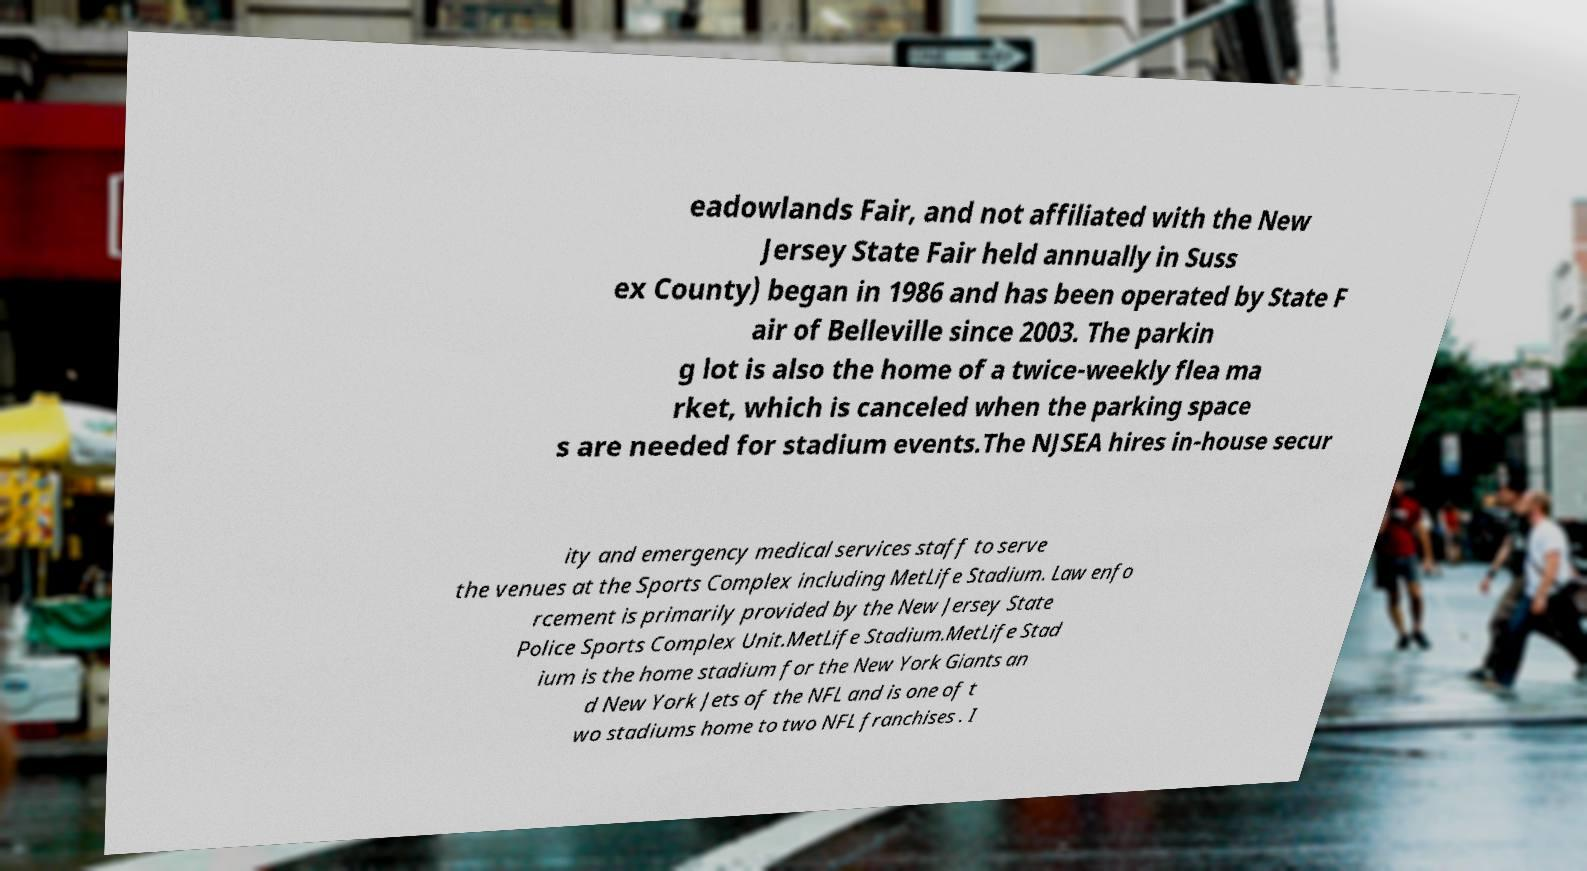For documentation purposes, I need the text within this image transcribed. Could you provide that? eadowlands Fair, and not affiliated with the New Jersey State Fair held annually in Suss ex County) began in 1986 and has been operated by State F air of Belleville since 2003. The parkin g lot is also the home of a twice-weekly flea ma rket, which is canceled when the parking space s are needed for stadium events.The NJSEA hires in-house secur ity and emergency medical services staff to serve the venues at the Sports Complex including MetLife Stadium. Law enfo rcement is primarily provided by the New Jersey State Police Sports Complex Unit.MetLife Stadium.MetLife Stad ium is the home stadium for the New York Giants an d New York Jets of the NFL and is one of t wo stadiums home to two NFL franchises . I 